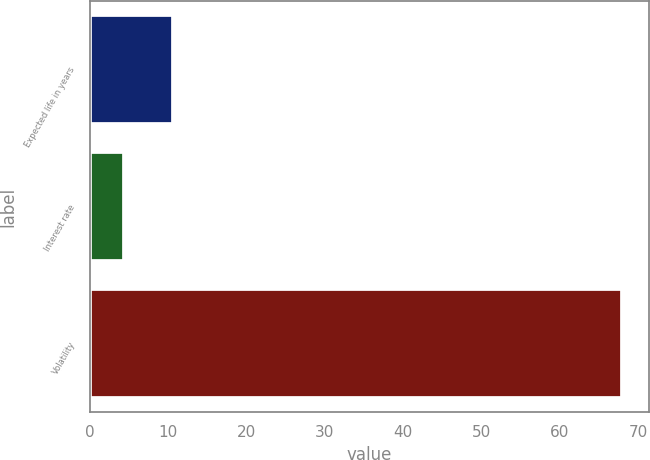Convert chart. <chart><loc_0><loc_0><loc_500><loc_500><bar_chart><fcel>Expected life in years<fcel>Interest rate<fcel>Volatility<nl><fcel>10.67<fcel>4.3<fcel>68<nl></chart> 